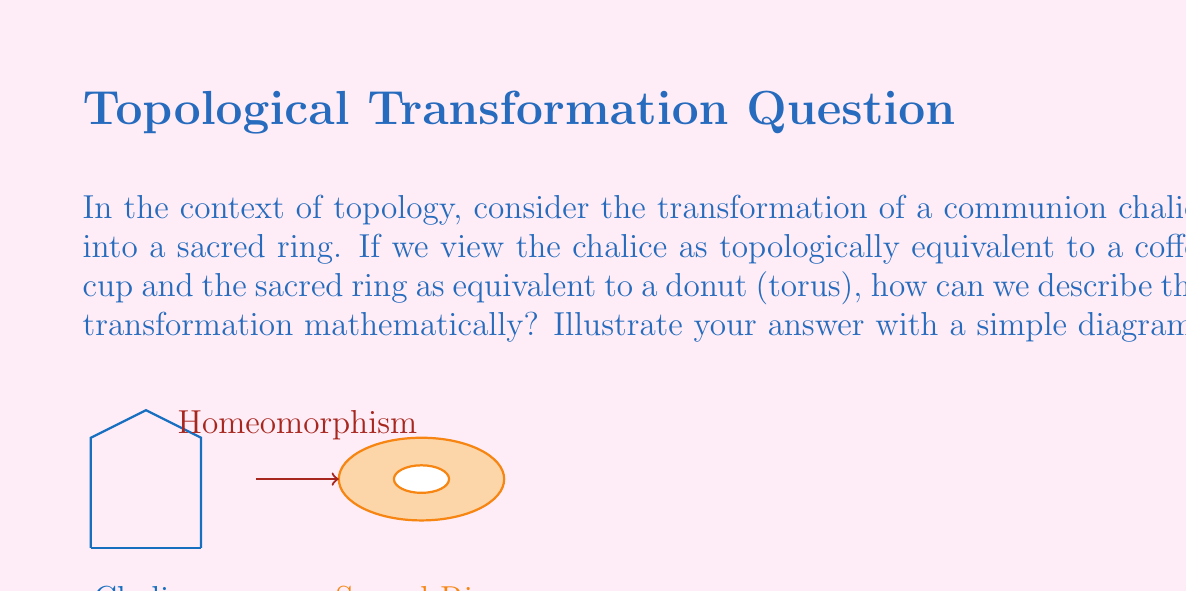Could you help me with this problem? To understand this transformation, we need to consider the concept of homeomorphism in topology:

1. Definition: A homeomorphism is a continuous function between topological spaces that has a continuous inverse function. Homeomorphic objects have the same topological properties.

2. The chalice (coffee cup) and the sacred ring (donut) are homeomorphic because:
   a) Both have exactly one hole (the handle of the cup and the hole of the donut).
   b) Both are orientable surfaces.
   c) Both have no boundary.

3. The transformation can be visualized as follows:
   a) Imagine the chalice is made of a flexible material.
   b) Gradually push the bottom of the cup upwards into the bowl.
   c) Simultaneously, widen and shorten the handle.
   d) Continue until the cup's bowl becomes the outer part of the donut and the handle forms the inner hole.

4. Mathematically, we can describe this using a continuous deformation function $f: X \rightarrow Y$ where $X$ is the chalice space and $Y$ is the sacred ring space.

5. The function $f$ must be bijective, continuous, and have a continuous inverse $f^{-1}$.

6. In terms of coordinates, if we parameterize the chalice surface as $(x,y,z)$ and the donut as $(u,v,w)$, we need to find a smooth, invertible mapping between these coordinate systems.

7. The Euler characteristic $\chi$ remains invariant under this transformation:
   $$\chi = V - E + F = 2 - 2g$$
   where $V$, $E$, and $F$ are vertices, edges, and faces in a triangulation, and $g$ is the genus (number of holes). For both the chalice and the sacred ring, $g = 1$, so $\chi = 0$.

This transformation preserves all topological properties while changing the geometric shape, exemplifying the essence of homeomorphism in topology.
Answer: The chalice and sacred ring are homeomorphic, preserving topological properties through continuous deformation. 